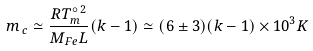<formula> <loc_0><loc_0><loc_500><loc_500>m _ { \, c } \simeq \frac { R T _ { m } ^ { \circ \, 2 } } { M _ { F e } L } ( k - 1 ) \simeq ( 6 \pm 3 ) ( k - 1 ) \times 1 0 ^ { 3 } K</formula> 